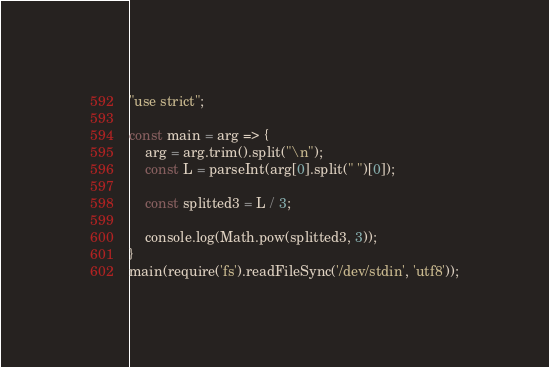<code> <loc_0><loc_0><loc_500><loc_500><_JavaScript_>"use strict";
    
const main = arg => {
    arg = arg.trim().split("\n");
    const L = parseInt(arg[0].split(" ")[0]);
    
    const splitted3 = L / 3;
    
    console.log(Math.pow(splitted3, 3));
}
main(require('fs').readFileSync('/dev/stdin', 'utf8'));</code> 